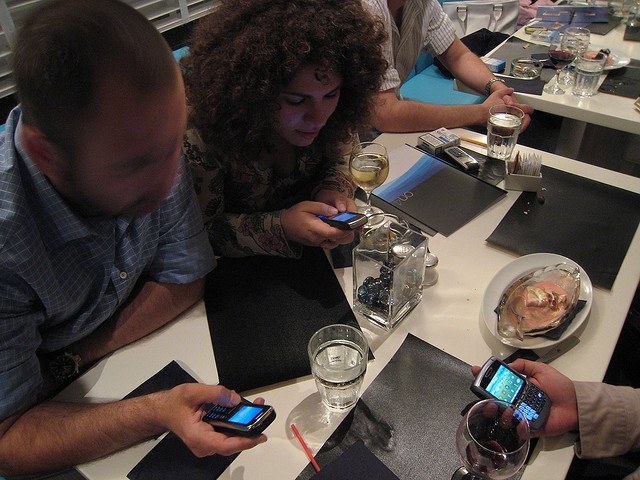Describe the objects in this image and their specific colors. I can see people in gray, black, maroon, and brown tones, dining table in gray, black, darkgray, and tan tones, people in gray, black, maroon, and brown tones, dining table in gray, black, darkgray, and tan tones, and people in gray, brown, and maroon tones in this image. 